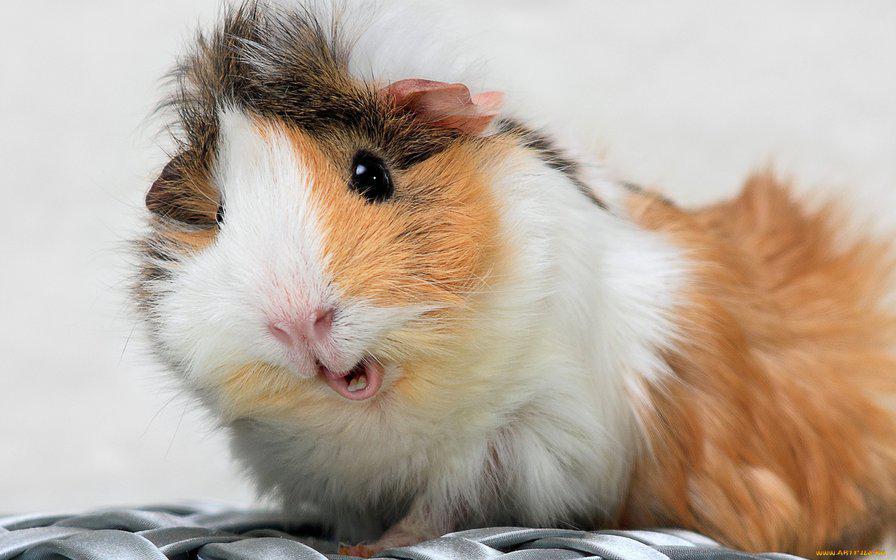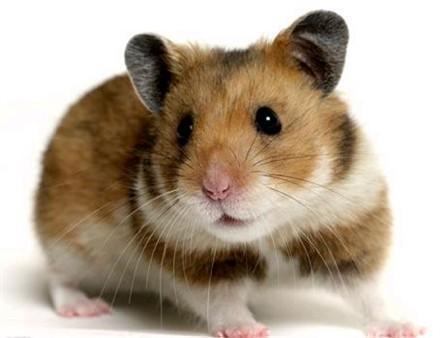The first image is the image on the left, the second image is the image on the right. For the images shown, is this caption "There is at least one animal whose eyes you cannot see at all." true? Answer yes or no. No. The first image is the image on the left, the second image is the image on the right. Analyze the images presented: Is the assertion "One of the images shows a gerbil whose eyes are not visible." valid? Answer yes or no. No. 